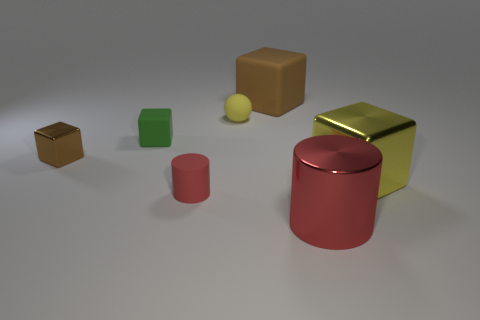There is a small yellow thing that is made of the same material as the green thing; what is its shape?
Give a very brief answer. Sphere. There is a big cube that is behind the shiny thing on the left side of the big metal object that is left of the large yellow object; what is its material?
Offer a terse response. Rubber. How many objects are either cylinders to the right of the big brown cube or large yellow shiny cubes?
Ensure brevity in your answer.  2. What number of other things are the same shape as the big yellow metallic thing?
Your response must be concise. 3. Is the number of green things to the left of the yellow ball greater than the number of big gray blocks?
Your response must be concise. Yes. What is the size of the yellow shiny thing that is the same shape as the big brown thing?
Ensure brevity in your answer.  Large. What is the shape of the red matte thing?
Keep it short and to the point. Cylinder. There is a red thing that is the same size as the brown matte cube; what shape is it?
Your answer should be compact. Cylinder. Is there any other thing that has the same color as the large cylinder?
Your answer should be compact. Yes. The brown cube that is the same material as the tiny ball is what size?
Give a very brief answer. Large. 